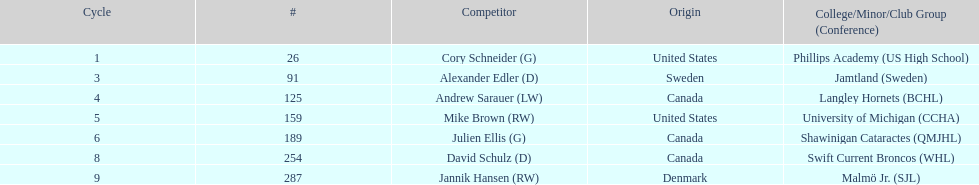Which player was the first player to be drafted? Cory Schneider (G). 